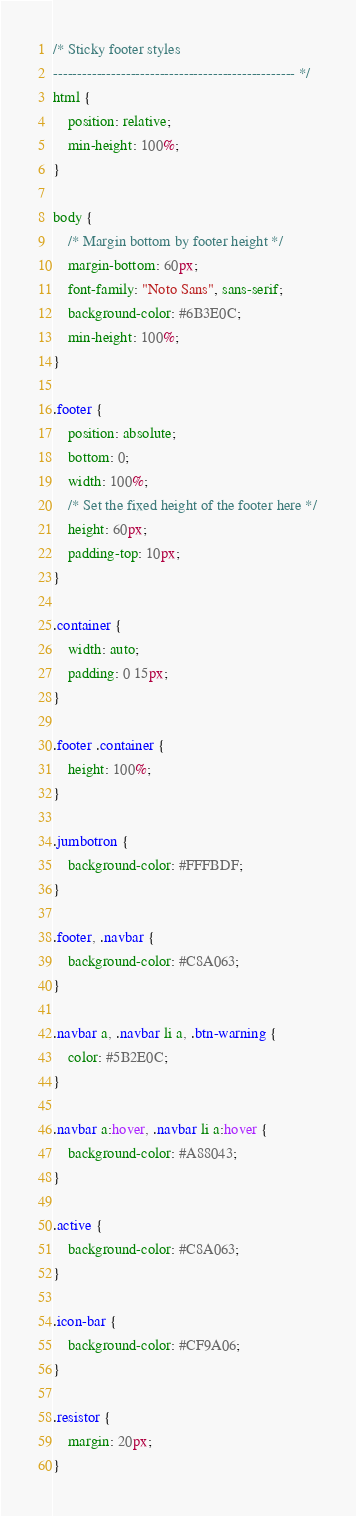Convert code to text. <code><loc_0><loc_0><loc_500><loc_500><_CSS_>/* Sticky footer styles
-------------------------------------------------- */
html {
    position: relative;
    min-height: 100%;
}

body {
    /* Margin bottom by footer height */
    margin-bottom: 60px;
    font-family: "Noto Sans", sans-serif;
    background-color: #6B3E0C;
    min-height: 100%;
}

.footer {
    position: absolute;
    bottom: 0;
    width: 100%;
    /* Set the fixed height of the footer here */
    height: 60px;
    padding-top: 10px;
}

.container {
    width: auto;
    padding: 0 15px;
}

.footer .container {
    height: 100%;
}

.jumbotron {
    background-color: #FFFBDF;
}

.footer, .navbar {
    background-color: #C8A063;
}

.navbar a, .navbar li a, .btn-warning {
    color: #5B2E0C;
}

.navbar a:hover, .navbar li a:hover {
    background-color: #A88043;
}

.active {
    background-color: #C8A063;
}

.icon-bar {
    background-color: #CF9A06;
}

.resistor {
    margin: 20px;
}
</code> 